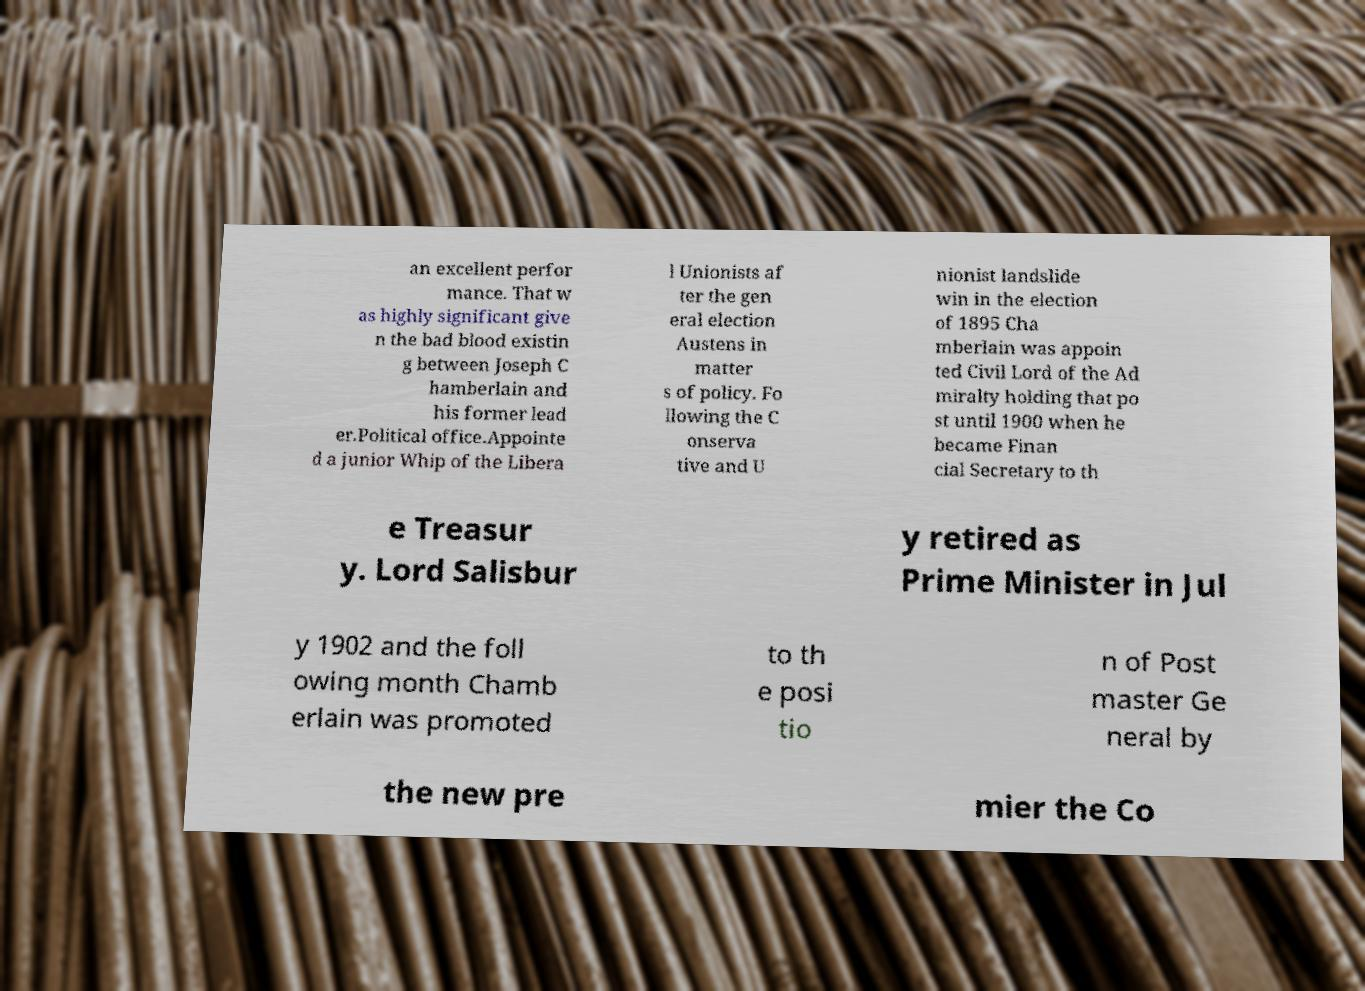Please read and relay the text visible in this image. What does it say? an excellent perfor mance. That w as highly significant give n the bad blood existin g between Joseph C hamberlain and his former lead er.Political office.Appointe d a junior Whip of the Libera l Unionists af ter the gen eral election Austens in matter s of policy. Fo llowing the C onserva tive and U nionist landslide win in the election of 1895 Cha mberlain was appoin ted Civil Lord of the Ad miralty holding that po st until 1900 when he became Finan cial Secretary to th e Treasur y. Lord Salisbur y retired as Prime Minister in Jul y 1902 and the foll owing month Chamb erlain was promoted to th e posi tio n of Post master Ge neral by the new pre mier the Co 